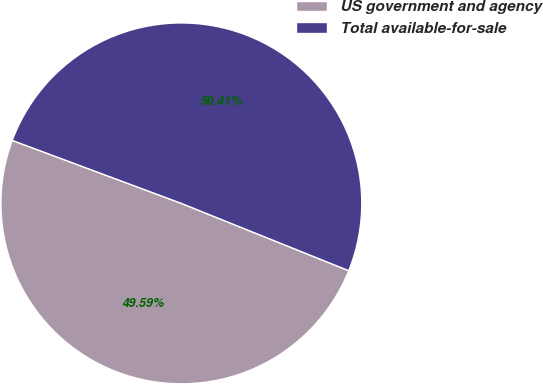<chart> <loc_0><loc_0><loc_500><loc_500><pie_chart><fcel>US government and agency<fcel>Total available-for-sale<nl><fcel>49.59%<fcel>50.41%<nl></chart> 